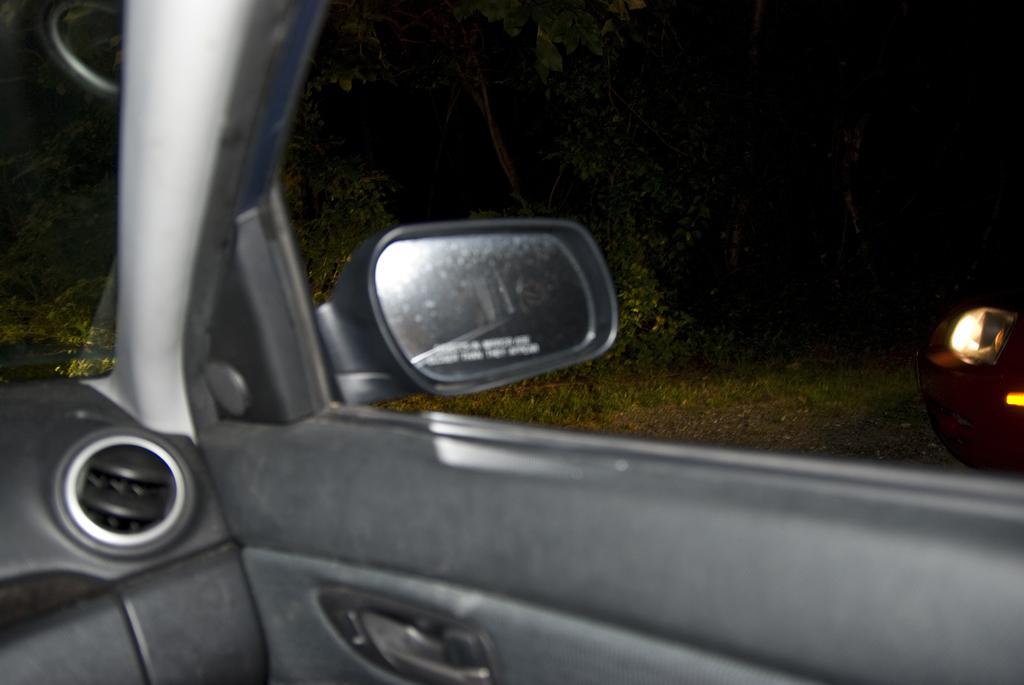Could you give a brief overview of what you see in this image? In front of the image there is a car door with handle, beside the door there is a side mirror and there is a windshield and Ac vent, from the car we can see trees on the outside and there is another car. 